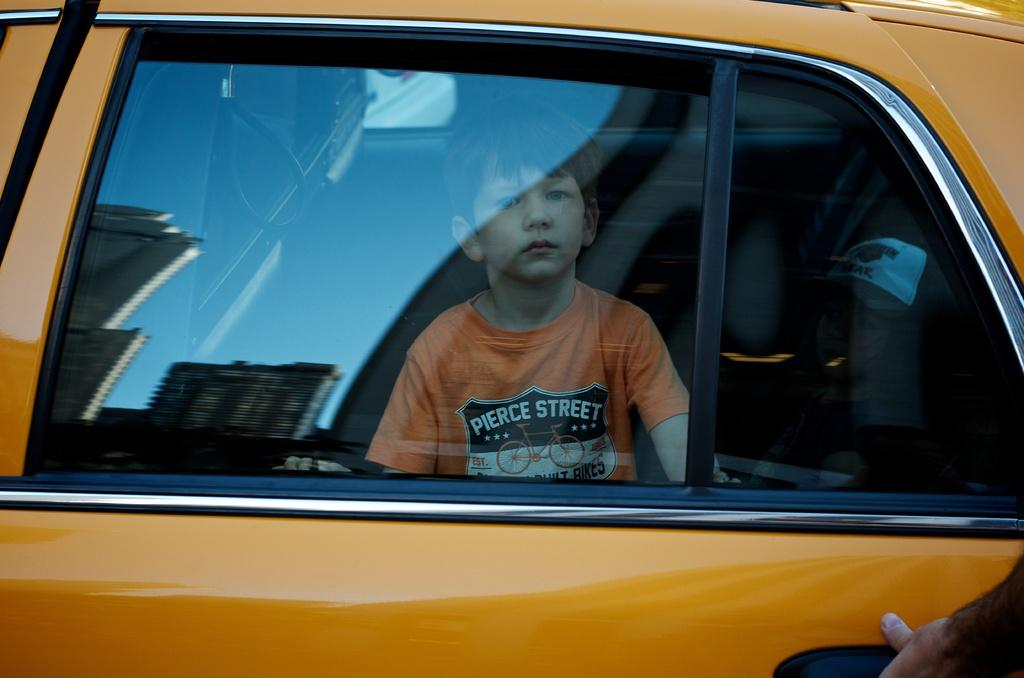What is inside the vehicle in the image? There is a boy inside the vehicle. What can be seen in the reflection on the glass of the vehicle? The glass of the vehicle has a reflection of buildings. What type of oil can be seen dripping from the impulse in the image? There is no impulse or oil present in the image. What color is the brick used to build the vehicle in the image? The vehicle is not made of brick, and there is no indication of its construction material in the image. 